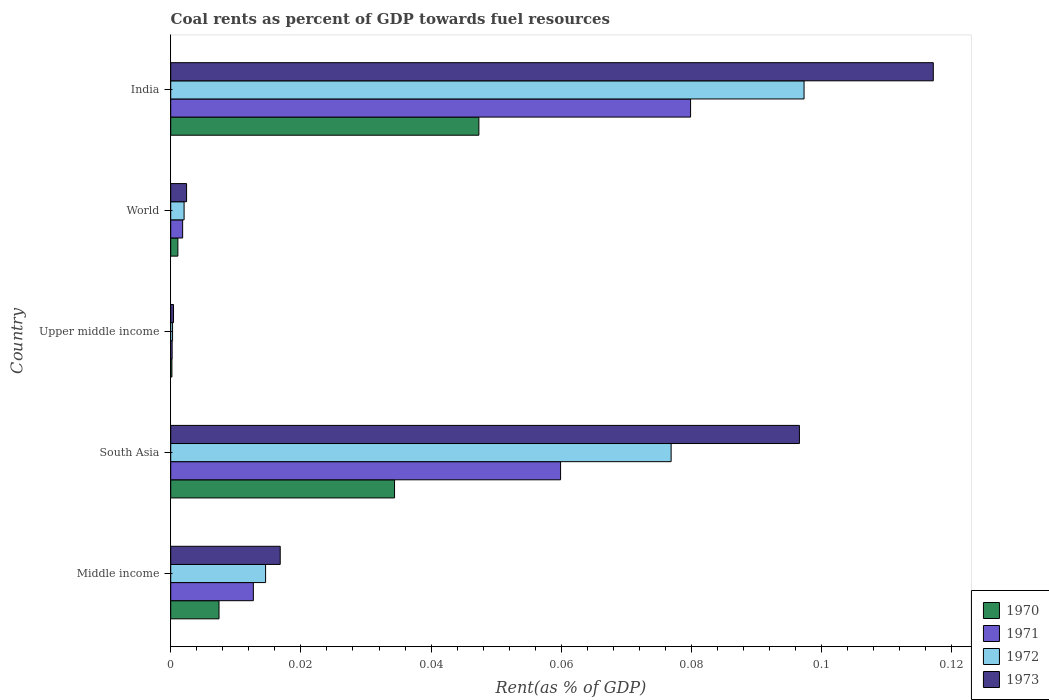Are the number of bars per tick equal to the number of legend labels?
Offer a very short reply. Yes. How many bars are there on the 1st tick from the top?
Provide a short and direct response. 4. How many bars are there on the 5th tick from the bottom?
Provide a succinct answer. 4. In how many cases, is the number of bars for a given country not equal to the number of legend labels?
Give a very brief answer. 0. What is the coal rent in 1971 in Middle income?
Provide a short and direct response. 0.01. Across all countries, what is the maximum coal rent in 1971?
Offer a very short reply. 0.08. Across all countries, what is the minimum coal rent in 1970?
Provide a short and direct response. 0. In which country was the coal rent in 1972 minimum?
Offer a very short reply. Upper middle income. What is the total coal rent in 1972 in the graph?
Provide a succinct answer. 0.19. What is the difference between the coal rent in 1970 in India and that in Middle income?
Keep it short and to the point. 0.04. What is the difference between the coal rent in 1973 in South Asia and the coal rent in 1971 in World?
Make the answer very short. 0.09. What is the average coal rent in 1971 per country?
Your answer should be compact. 0.03. What is the difference between the coal rent in 1973 and coal rent in 1971 in Middle income?
Provide a short and direct response. 0. What is the ratio of the coal rent in 1970 in Upper middle income to that in World?
Offer a very short reply. 0.17. Is the coal rent in 1971 in India less than that in World?
Give a very brief answer. No. Is the difference between the coal rent in 1973 in India and World greater than the difference between the coal rent in 1971 in India and World?
Your response must be concise. Yes. What is the difference between the highest and the second highest coal rent in 1970?
Ensure brevity in your answer.  0.01. What is the difference between the highest and the lowest coal rent in 1972?
Ensure brevity in your answer.  0.1. What does the 1st bar from the top in Upper middle income represents?
Your answer should be compact. 1973. How many countries are there in the graph?
Provide a short and direct response. 5. What is the difference between two consecutive major ticks on the X-axis?
Keep it short and to the point. 0.02. Does the graph contain any zero values?
Keep it short and to the point. No. Does the graph contain grids?
Keep it short and to the point. No. How many legend labels are there?
Provide a succinct answer. 4. How are the legend labels stacked?
Give a very brief answer. Vertical. What is the title of the graph?
Provide a succinct answer. Coal rents as percent of GDP towards fuel resources. What is the label or title of the X-axis?
Ensure brevity in your answer.  Rent(as % of GDP). What is the Rent(as % of GDP) of 1970 in Middle income?
Provide a succinct answer. 0.01. What is the Rent(as % of GDP) in 1971 in Middle income?
Provide a short and direct response. 0.01. What is the Rent(as % of GDP) in 1972 in Middle income?
Keep it short and to the point. 0.01. What is the Rent(as % of GDP) in 1973 in Middle income?
Keep it short and to the point. 0.02. What is the Rent(as % of GDP) in 1970 in South Asia?
Offer a very short reply. 0.03. What is the Rent(as % of GDP) in 1971 in South Asia?
Your answer should be compact. 0.06. What is the Rent(as % of GDP) in 1972 in South Asia?
Your answer should be very brief. 0.08. What is the Rent(as % of GDP) of 1973 in South Asia?
Your response must be concise. 0.1. What is the Rent(as % of GDP) of 1970 in Upper middle income?
Provide a short and direct response. 0. What is the Rent(as % of GDP) in 1971 in Upper middle income?
Keep it short and to the point. 0. What is the Rent(as % of GDP) of 1972 in Upper middle income?
Keep it short and to the point. 0. What is the Rent(as % of GDP) of 1973 in Upper middle income?
Give a very brief answer. 0. What is the Rent(as % of GDP) of 1970 in World?
Your response must be concise. 0. What is the Rent(as % of GDP) of 1971 in World?
Give a very brief answer. 0. What is the Rent(as % of GDP) of 1972 in World?
Give a very brief answer. 0. What is the Rent(as % of GDP) in 1973 in World?
Your response must be concise. 0. What is the Rent(as % of GDP) in 1970 in India?
Your answer should be compact. 0.05. What is the Rent(as % of GDP) of 1971 in India?
Your answer should be compact. 0.08. What is the Rent(as % of GDP) of 1972 in India?
Give a very brief answer. 0.1. What is the Rent(as % of GDP) of 1973 in India?
Provide a succinct answer. 0.12. Across all countries, what is the maximum Rent(as % of GDP) in 1970?
Ensure brevity in your answer.  0.05. Across all countries, what is the maximum Rent(as % of GDP) in 1971?
Ensure brevity in your answer.  0.08. Across all countries, what is the maximum Rent(as % of GDP) of 1972?
Ensure brevity in your answer.  0.1. Across all countries, what is the maximum Rent(as % of GDP) of 1973?
Offer a very short reply. 0.12. Across all countries, what is the minimum Rent(as % of GDP) in 1970?
Offer a very short reply. 0. Across all countries, what is the minimum Rent(as % of GDP) of 1971?
Offer a very short reply. 0. Across all countries, what is the minimum Rent(as % of GDP) of 1972?
Your answer should be compact. 0. Across all countries, what is the minimum Rent(as % of GDP) of 1973?
Ensure brevity in your answer.  0. What is the total Rent(as % of GDP) in 1970 in the graph?
Make the answer very short. 0.09. What is the total Rent(as % of GDP) of 1971 in the graph?
Provide a short and direct response. 0.15. What is the total Rent(as % of GDP) of 1972 in the graph?
Your answer should be very brief. 0.19. What is the total Rent(as % of GDP) in 1973 in the graph?
Your response must be concise. 0.23. What is the difference between the Rent(as % of GDP) of 1970 in Middle income and that in South Asia?
Give a very brief answer. -0.03. What is the difference between the Rent(as % of GDP) in 1971 in Middle income and that in South Asia?
Ensure brevity in your answer.  -0.05. What is the difference between the Rent(as % of GDP) of 1972 in Middle income and that in South Asia?
Keep it short and to the point. -0.06. What is the difference between the Rent(as % of GDP) of 1973 in Middle income and that in South Asia?
Ensure brevity in your answer.  -0.08. What is the difference between the Rent(as % of GDP) of 1970 in Middle income and that in Upper middle income?
Offer a terse response. 0.01. What is the difference between the Rent(as % of GDP) in 1971 in Middle income and that in Upper middle income?
Keep it short and to the point. 0.01. What is the difference between the Rent(as % of GDP) in 1972 in Middle income and that in Upper middle income?
Give a very brief answer. 0.01. What is the difference between the Rent(as % of GDP) in 1973 in Middle income and that in Upper middle income?
Your answer should be very brief. 0.02. What is the difference between the Rent(as % of GDP) of 1970 in Middle income and that in World?
Your response must be concise. 0.01. What is the difference between the Rent(as % of GDP) of 1971 in Middle income and that in World?
Your answer should be very brief. 0.01. What is the difference between the Rent(as % of GDP) in 1972 in Middle income and that in World?
Offer a very short reply. 0.01. What is the difference between the Rent(as % of GDP) in 1973 in Middle income and that in World?
Provide a short and direct response. 0.01. What is the difference between the Rent(as % of GDP) in 1970 in Middle income and that in India?
Provide a succinct answer. -0.04. What is the difference between the Rent(as % of GDP) of 1971 in Middle income and that in India?
Your response must be concise. -0.07. What is the difference between the Rent(as % of GDP) of 1972 in Middle income and that in India?
Make the answer very short. -0.08. What is the difference between the Rent(as % of GDP) in 1973 in Middle income and that in India?
Offer a terse response. -0.1. What is the difference between the Rent(as % of GDP) of 1970 in South Asia and that in Upper middle income?
Your answer should be compact. 0.03. What is the difference between the Rent(as % of GDP) of 1971 in South Asia and that in Upper middle income?
Provide a succinct answer. 0.06. What is the difference between the Rent(as % of GDP) of 1972 in South Asia and that in Upper middle income?
Make the answer very short. 0.08. What is the difference between the Rent(as % of GDP) in 1973 in South Asia and that in Upper middle income?
Offer a very short reply. 0.1. What is the difference between the Rent(as % of GDP) in 1971 in South Asia and that in World?
Offer a very short reply. 0.06. What is the difference between the Rent(as % of GDP) in 1972 in South Asia and that in World?
Provide a short and direct response. 0.07. What is the difference between the Rent(as % of GDP) of 1973 in South Asia and that in World?
Make the answer very short. 0.09. What is the difference between the Rent(as % of GDP) of 1970 in South Asia and that in India?
Provide a succinct answer. -0.01. What is the difference between the Rent(as % of GDP) of 1971 in South Asia and that in India?
Provide a succinct answer. -0.02. What is the difference between the Rent(as % of GDP) of 1972 in South Asia and that in India?
Your answer should be compact. -0.02. What is the difference between the Rent(as % of GDP) of 1973 in South Asia and that in India?
Provide a succinct answer. -0.02. What is the difference between the Rent(as % of GDP) in 1970 in Upper middle income and that in World?
Keep it short and to the point. -0. What is the difference between the Rent(as % of GDP) in 1971 in Upper middle income and that in World?
Provide a short and direct response. -0. What is the difference between the Rent(as % of GDP) of 1972 in Upper middle income and that in World?
Make the answer very short. -0. What is the difference between the Rent(as % of GDP) in 1973 in Upper middle income and that in World?
Make the answer very short. -0. What is the difference between the Rent(as % of GDP) of 1970 in Upper middle income and that in India?
Ensure brevity in your answer.  -0.05. What is the difference between the Rent(as % of GDP) of 1971 in Upper middle income and that in India?
Provide a succinct answer. -0.08. What is the difference between the Rent(as % of GDP) of 1972 in Upper middle income and that in India?
Your response must be concise. -0.1. What is the difference between the Rent(as % of GDP) of 1973 in Upper middle income and that in India?
Provide a short and direct response. -0.12. What is the difference between the Rent(as % of GDP) in 1970 in World and that in India?
Your answer should be very brief. -0.05. What is the difference between the Rent(as % of GDP) in 1971 in World and that in India?
Keep it short and to the point. -0.08. What is the difference between the Rent(as % of GDP) of 1972 in World and that in India?
Provide a succinct answer. -0.1. What is the difference between the Rent(as % of GDP) in 1973 in World and that in India?
Offer a terse response. -0.11. What is the difference between the Rent(as % of GDP) of 1970 in Middle income and the Rent(as % of GDP) of 1971 in South Asia?
Make the answer very short. -0.05. What is the difference between the Rent(as % of GDP) of 1970 in Middle income and the Rent(as % of GDP) of 1972 in South Asia?
Offer a very short reply. -0.07. What is the difference between the Rent(as % of GDP) of 1970 in Middle income and the Rent(as % of GDP) of 1973 in South Asia?
Your answer should be very brief. -0.09. What is the difference between the Rent(as % of GDP) of 1971 in Middle income and the Rent(as % of GDP) of 1972 in South Asia?
Your answer should be very brief. -0.06. What is the difference between the Rent(as % of GDP) in 1971 in Middle income and the Rent(as % of GDP) in 1973 in South Asia?
Ensure brevity in your answer.  -0.08. What is the difference between the Rent(as % of GDP) of 1972 in Middle income and the Rent(as % of GDP) of 1973 in South Asia?
Your response must be concise. -0.08. What is the difference between the Rent(as % of GDP) of 1970 in Middle income and the Rent(as % of GDP) of 1971 in Upper middle income?
Your answer should be compact. 0.01. What is the difference between the Rent(as % of GDP) of 1970 in Middle income and the Rent(as % of GDP) of 1972 in Upper middle income?
Provide a short and direct response. 0.01. What is the difference between the Rent(as % of GDP) of 1970 in Middle income and the Rent(as % of GDP) of 1973 in Upper middle income?
Your answer should be compact. 0.01. What is the difference between the Rent(as % of GDP) of 1971 in Middle income and the Rent(as % of GDP) of 1972 in Upper middle income?
Provide a short and direct response. 0.01. What is the difference between the Rent(as % of GDP) of 1971 in Middle income and the Rent(as % of GDP) of 1973 in Upper middle income?
Your response must be concise. 0.01. What is the difference between the Rent(as % of GDP) in 1972 in Middle income and the Rent(as % of GDP) in 1973 in Upper middle income?
Provide a succinct answer. 0.01. What is the difference between the Rent(as % of GDP) of 1970 in Middle income and the Rent(as % of GDP) of 1971 in World?
Your answer should be compact. 0.01. What is the difference between the Rent(as % of GDP) in 1970 in Middle income and the Rent(as % of GDP) in 1972 in World?
Your answer should be compact. 0.01. What is the difference between the Rent(as % of GDP) of 1970 in Middle income and the Rent(as % of GDP) of 1973 in World?
Keep it short and to the point. 0.01. What is the difference between the Rent(as % of GDP) of 1971 in Middle income and the Rent(as % of GDP) of 1972 in World?
Provide a short and direct response. 0.01. What is the difference between the Rent(as % of GDP) of 1971 in Middle income and the Rent(as % of GDP) of 1973 in World?
Your response must be concise. 0.01. What is the difference between the Rent(as % of GDP) of 1972 in Middle income and the Rent(as % of GDP) of 1973 in World?
Keep it short and to the point. 0.01. What is the difference between the Rent(as % of GDP) in 1970 in Middle income and the Rent(as % of GDP) in 1971 in India?
Ensure brevity in your answer.  -0.07. What is the difference between the Rent(as % of GDP) of 1970 in Middle income and the Rent(as % of GDP) of 1972 in India?
Ensure brevity in your answer.  -0.09. What is the difference between the Rent(as % of GDP) of 1970 in Middle income and the Rent(as % of GDP) of 1973 in India?
Your response must be concise. -0.11. What is the difference between the Rent(as % of GDP) of 1971 in Middle income and the Rent(as % of GDP) of 1972 in India?
Your answer should be compact. -0.08. What is the difference between the Rent(as % of GDP) of 1971 in Middle income and the Rent(as % of GDP) of 1973 in India?
Give a very brief answer. -0.1. What is the difference between the Rent(as % of GDP) of 1972 in Middle income and the Rent(as % of GDP) of 1973 in India?
Offer a very short reply. -0.1. What is the difference between the Rent(as % of GDP) in 1970 in South Asia and the Rent(as % of GDP) in 1971 in Upper middle income?
Provide a short and direct response. 0.03. What is the difference between the Rent(as % of GDP) of 1970 in South Asia and the Rent(as % of GDP) of 1972 in Upper middle income?
Offer a terse response. 0.03. What is the difference between the Rent(as % of GDP) in 1970 in South Asia and the Rent(as % of GDP) in 1973 in Upper middle income?
Keep it short and to the point. 0.03. What is the difference between the Rent(as % of GDP) of 1971 in South Asia and the Rent(as % of GDP) of 1972 in Upper middle income?
Provide a short and direct response. 0.06. What is the difference between the Rent(as % of GDP) in 1971 in South Asia and the Rent(as % of GDP) in 1973 in Upper middle income?
Give a very brief answer. 0.06. What is the difference between the Rent(as % of GDP) in 1972 in South Asia and the Rent(as % of GDP) in 1973 in Upper middle income?
Your response must be concise. 0.08. What is the difference between the Rent(as % of GDP) of 1970 in South Asia and the Rent(as % of GDP) of 1971 in World?
Offer a very short reply. 0.03. What is the difference between the Rent(as % of GDP) of 1970 in South Asia and the Rent(as % of GDP) of 1972 in World?
Ensure brevity in your answer.  0.03. What is the difference between the Rent(as % of GDP) in 1970 in South Asia and the Rent(as % of GDP) in 1973 in World?
Your response must be concise. 0.03. What is the difference between the Rent(as % of GDP) in 1971 in South Asia and the Rent(as % of GDP) in 1972 in World?
Ensure brevity in your answer.  0.06. What is the difference between the Rent(as % of GDP) in 1971 in South Asia and the Rent(as % of GDP) in 1973 in World?
Your answer should be compact. 0.06. What is the difference between the Rent(as % of GDP) of 1972 in South Asia and the Rent(as % of GDP) of 1973 in World?
Provide a succinct answer. 0.07. What is the difference between the Rent(as % of GDP) of 1970 in South Asia and the Rent(as % of GDP) of 1971 in India?
Keep it short and to the point. -0.05. What is the difference between the Rent(as % of GDP) in 1970 in South Asia and the Rent(as % of GDP) in 1972 in India?
Make the answer very short. -0.06. What is the difference between the Rent(as % of GDP) of 1970 in South Asia and the Rent(as % of GDP) of 1973 in India?
Your answer should be very brief. -0.08. What is the difference between the Rent(as % of GDP) in 1971 in South Asia and the Rent(as % of GDP) in 1972 in India?
Provide a short and direct response. -0.04. What is the difference between the Rent(as % of GDP) of 1971 in South Asia and the Rent(as % of GDP) of 1973 in India?
Provide a short and direct response. -0.06. What is the difference between the Rent(as % of GDP) in 1972 in South Asia and the Rent(as % of GDP) in 1973 in India?
Offer a very short reply. -0.04. What is the difference between the Rent(as % of GDP) in 1970 in Upper middle income and the Rent(as % of GDP) in 1971 in World?
Keep it short and to the point. -0. What is the difference between the Rent(as % of GDP) of 1970 in Upper middle income and the Rent(as % of GDP) of 1972 in World?
Offer a very short reply. -0. What is the difference between the Rent(as % of GDP) in 1970 in Upper middle income and the Rent(as % of GDP) in 1973 in World?
Provide a short and direct response. -0. What is the difference between the Rent(as % of GDP) in 1971 in Upper middle income and the Rent(as % of GDP) in 1972 in World?
Offer a very short reply. -0. What is the difference between the Rent(as % of GDP) of 1971 in Upper middle income and the Rent(as % of GDP) of 1973 in World?
Offer a very short reply. -0. What is the difference between the Rent(as % of GDP) in 1972 in Upper middle income and the Rent(as % of GDP) in 1973 in World?
Ensure brevity in your answer.  -0. What is the difference between the Rent(as % of GDP) in 1970 in Upper middle income and the Rent(as % of GDP) in 1971 in India?
Your answer should be compact. -0.08. What is the difference between the Rent(as % of GDP) of 1970 in Upper middle income and the Rent(as % of GDP) of 1972 in India?
Offer a terse response. -0.1. What is the difference between the Rent(as % of GDP) in 1970 in Upper middle income and the Rent(as % of GDP) in 1973 in India?
Keep it short and to the point. -0.12. What is the difference between the Rent(as % of GDP) of 1971 in Upper middle income and the Rent(as % of GDP) of 1972 in India?
Give a very brief answer. -0.1. What is the difference between the Rent(as % of GDP) of 1971 in Upper middle income and the Rent(as % of GDP) of 1973 in India?
Your response must be concise. -0.12. What is the difference between the Rent(as % of GDP) of 1972 in Upper middle income and the Rent(as % of GDP) of 1973 in India?
Ensure brevity in your answer.  -0.12. What is the difference between the Rent(as % of GDP) in 1970 in World and the Rent(as % of GDP) in 1971 in India?
Provide a succinct answer. -0.08. What is the difference between the Rent(as % of GDP) of 1970 in World and the Rent(as % of GDP) of 1972 in India?
Offer a very short reply. -0.1. What is the difference between the Rent(as % of GDP) in 1970 in World and the Rent(as % of GDP) in 1973 in India?
Your answer should be very brief. -0.12. What is the difference between the Rent(as % of GDP) in 1971 in World and the Rent(as % of GDP) in 1972 in India?
Your response must be concise. -0.1. What is the difference between the Rent(as % of GDP) of 1971 in World and the Rent(as % of GDP) of 1973 in India?
Make the answer very short. -0.12. What is the difference between the Rent(as % of GDP) of 1972 in World and the Rent(as % of GDP) of 1973 in India?
Your answer should be compact. -0.12. What is the average Rent(as % of GDP) in 1970 per country?
Give a very brief answer. 0.02. What is the average Rent(as % of GDP) in 1971 per country?
Provide a succinct answer. 0.03. What is the average Rent(as % of GDP) of 1972 per country?
Make the answer very short. 0.04. What is the average Rent(as % of GDP) in 1973 per country?
Keep it short and to the point. 0.05. What is the difference between the Rent(as % of GDP) in 1970 and Rent(as % of GDP) in 1971 in Middle income?
Provide a succinct answer. -0.01. What is the difference between the Rent(as % of GDP) in 1970 and Rent(as % of GDP) in 1972 in Middle income?
Your answer should be very brief. -0.01. What is the difference between the Rent(as % of GDP) of 1970 and Rent(as % of GDP) of 1973 in Middle income?
Give a very brief answer. -0.01. What is the difference between the Rent(as % of GDP) in 1971 and Rent(as % of GDP) in 1972 in Middle income?
Give a very brief answer. -0. What is the difference between the Rent(as % of GDP) of 1971 and Rent(as % of GDP) of 1973 in Middle income?
Keep it short and to the point. -0. What is the difference between the Rent(as % of GDP) in 1972 and Rent(as % of GDP) in 1973 in Middle income?
Ensure brevity in your answer.  -0. What is the difference between the Rent(as % of GDP) of 1970 and Rent(as % of GDP) of 1971 in South Asia?
Offer a very short reply. -0.03. What is the difference between the Rent(as % of GDP) of 1970 and Rent(as % of GDP) of 1972 in South Asia?
Ensure brevity in your answer.  -0.04. What is the difference between the Rent(as % of GDP) in 1970 and Rent(as % of GDP) in 1973 in South Asia?
Make the answer very short. -0.06. What is the difference between the Rent(as % of GDP) of 1971 and Rent(as % of GDP) of 1972 in South Asia?
Offer a terse response. -0.02. What is the difference between the Rent(as % of GDP) in 1971 and Rent(as % of GDP) in 1973 in South Asia?
Offer a very short reply. -0.04. What is the difference between the Rent(as % of GDP) of 1972 and Rent(as % of GDP) of 1973 in South Asia?
Your response must be concise. -0.02. What is the difference between the Rent(as % of GDP) in 1970 and Rent(as % of GDP) in 1972 in Upper middle income?
Provide a short and direct response. -0. What is the difference between the Rent(as % of GDP) of 1970 and Rent(as % of GDP) of 1973 in Upper middle income?
Make the answer very short. -0. What is the difference between the Rent(as % of GDP) in 1971 and Rent(as % of GDP) in 1972 in Upper middle income?
Ensure brevity in your answer.  -0. What is the difference between the Rent(as % of GDP) in 1971 and Rent(as % of GDP) in 1973 in Upper middle income?
Your answer should be very brief. -0. What is the difference between the Rent(as % of GDP) of 1972 and Rent(as % of GDP) of 1973 in Upper middle income?
Offer a terse response. -0. What is the difference between the Rent(as % of GDP) in 1970 and Rent(as % of GDP) in 1971 in World?
Offer a very short reply. -0. What is the difference between the Rent(as % of GDP) of 1970 and Rent(as % of GDP) of 1972 in World?
Keep it short and to the point. -0. What is the difference between the Rent(as % of GDP) in 1970 and Rent(as % of GDP) in 1973 in World?
Your answer should be compact. -0. What is the difference between the Rent(as % of GDP) of 1971 and Rent(as % of GDP) of 1972 in World?
Your answer should be compact. -0. What is the difference between the Rent(as % of GDP) of 1971 and Rent(as % of GDP) of 1973 in World?
Keep it short and to the point. -0. What is the difference between the Rent(as % of GDP) in 1972 and Rent(as % of GDP) in 1973 in World?
Your answer should be compact. -0. What is the difference between the Rent(as % of GDP) in 1970 and Rent(as % of GDP) in 1971 in India?
Provide a succinct answer. -0.03. What is the difference between the Rent(as % of GDP) in 1970 and Rent(as % of GDP) in 1972 in India?
Offer a very short reply. -0.05. What is the difference between the Rent(as % of GDP) of 1970 and Rent(as % of GDP) of 1973 in India?
Ensure brevity in your answer.  -0.07. What is the difference between the Rent(as % of GDP) in 1971 and Rent(as % of GDP) in 1972 in India?
Ensure brevity in your answer.  -0.02. What is the difference between the Rent(as % of GDP) in 1971 and Rent(as % of GDP) in 1973 in India?
Your response must be concise. -0.04. What is the difference between the Rent(as % of GDP) in 1972 and Rent(as % of GDP) in 1973 in India?
Keep it short and to the point. -0.02. What is the ratio of the Rent(as % of GDP) of 1970 in Middle income to that in South Asia?
Offer a terse response. 0.22. What is the ratio of the Rent(as % of GDP) in 1971 in Middle income to that in South Asia?
Keep it short and to the point. 0.21. What is the ratio of the Rent(as % of GDP) in 1972 in Middle income to that in South Asia?
Provide a short and direct response. 0.19. What is the ratio of the Rent(as % of GDP) of 1973 in Middle income to that in South Asia?
Keep it short and to the point. 0.17. What is the ratio of the Rent(as % of GDP) of 1970 in Middle income to that in Upper middle income?
Make the answer very short. 40.36. What is the ratio of the Rent(as % of GDP) of 1971 in Middle income to that in Upper middle income?
Offer a terse response. 58.01. What is the ratio of the Rent(as % of GDP) in 1972 in Middle income to that in Upper middle income?
Your response must be concise. 51.25. What is the ratio of the Rent(as % of GDP) in 1973 in Middle income to that in Upper middle income?
Offer a terse response. 39.04. What is the ratio of the Rent(as % of GDP) in 1970 in Middle income to that in World?
Make the answer very short. 6.74. What is the ratio of the Rent(as % of GDP) of 1971 in Middle income to that in World?
Provide a succinct answer. 6.93. What is the ratio of the Rent(as % of GDP) of 1972 in Middle income to that in World?
Offer a terse response. 7.09. What is the ratio of the Rent(as % of GDP) in 1973 in Middle income to that in World?
Offer a very short reply. 6.91. What is the ratio of the Rent(as % of GDP) in 1970 in Middle income to that in India?
Provide a short and direct response. 0.16. What is the ratio of the Rent(as % of GDP) in 1971 in Middle income to that in India?
Provide a short and direct response. 0.16. What is the ratio of the Rent(as % of GDP) in 1972 in Middle income to that in India?
Provide a short and direct response. 0.15. What is the ratio of the Rent(as % of GDP) of 1973 in Middle income to that in India?
Provide a succinct answer. 0.14. What is the ratio of the Rent(as % of GDP) of 1970 in South Asia to that in Upper middle income?
Ensure brevity in your answer.  187.05. What is the ratio of the Rent(as % of GDP) in 1971 in South Asia to that in Upper middle income?
Your response must be concise. 273.74. What is the ratio of the Rent(as % of GDP) in 1972 in South Asia to that in Upper middle income?
Your response must be concise. 270.32. What is the ratio of the Rent(as % of GDP) in 1973 in South Asia to that in Upper middle income?
Offer a very short reply. 224.18. What is the ratio of the Rent(as % of GDP) of 1970 in South Asia to that in World?
Give a very brief answer. 31.24. What is the ratio of the Rent(as % of GDP) in 1971 in South Asia to that in World?
Ensure brevity in your answer.  32.69. What is the ratio of the Rent(as % of GDP) in 1972 in South Asia to that in World?
Provide a succinct answer. 37.41. What is the ratio of the Rent(as % of GDP) of 1973 in South Asia to that in World?
Offer a very short reply. 39.65. What is the ratio of the Rent(as % of GDP) in 1970 in South Asia to that in India?
Your response must be concise. 0.73. What is the ratio of the Rent(as % of GDP) of 1971 in South Asia to that in India?
Ensure brevity in your answer.  0.75. What is the ratio of the Rent(as % of GDP) of 1972 in South Asia to that in India?
Your answer should be very brief. 0.79. What is the ratio of the Rent(as % of GDP) of 1973 in South Asia to that in India?
Give a very brief answer. 0.82. What is the ratio of the Rent(as % of GDP) in 1970 in Upper middle income to that in World?
Your response must be concise. 0.17. What is the ratio of the Rent(as % of GDP) in 1971 in Upper middle income to that in World?
Offer a terse response. 0.12. What is the ratio of the Rent(as % of GDP) in 1972 in Upper middle income to that in World?
Ensure brevity in your answer.  0.14. What is the ratio of the Rent(as % of GDP) in 1973 in Upper middle income to that in World?
Your answer should be very brief. 0.18. What is the ratio of the Rent(as % of GDP) of 1970 in Upper middle income to that in India?
Provide a succinct answer. 0. What is the ratio of the Rent(as % of GDP) in 1971 in Upper middle income to that in India?
Your response must be concise. 0. What is the ratio of the Rent(as % of GDP) in 1972 in Upper middle income to that in India?
Ensure brevity in your answer.  0. What is the ratio of the Rent(as % of GDP) of 1973 in Upper middle income to that in India?
Keep it short and to the point. 0. What is the ratio of the Rent(as % of GDP) of 1970 in World to that in India?
Provide a succinct answer. 0.02. What is the ratio of the Rent(as % of GDP) of 1971 in World to that in India?
Your answer should be very brief. 0.02. What is the ratio of the Rent(as % of GDP) in 1972 in World to that in India?
Keep it short and to the point. 0.02. What is the ratio of the Rent(as % of GDP) of 1973 in World to that in India?
Offer a very short reply. 0.02. What is the difference between the highest and the second highest Rent(as % of GDP) of 1970?
Your response must be concise. 0.01. What is the difference between the highest and the second highest Rent(as % of GDP) of 1971?
Your response must be concise. 0.02. What is the difference between the highest and the second highest Rent(as % of GDP) in 1972?
Offer a very short reply. 0.02. What is the difference between the highest and the second highest Rent(as % of GDP) in 1973?
Your response must be concise. 0.02. What is the difference between the highest and the lowest Rent(as % of GDP) in 1970?
Keep it short and to the point. 0.05. What is the difference between the highest and the lowest Rent(as % of GDP) in 1971?
Your answer should be very brief. 0.08. What is the difference between the highest and the lowest Rent(as % of GDP) of 1972?
Your answer should be very brief. 0.1. What is the difference between the highest and the lowest Rent(as % of GDP) of 1973?
Offer a very short reply. 0.12. 